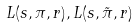Convert formula to latex. <formula><loc_0><loc_0><loc_500><loc_500>L ( s , \pi , r ) , L ( s , \tilde { \pi } , r )</formula> 